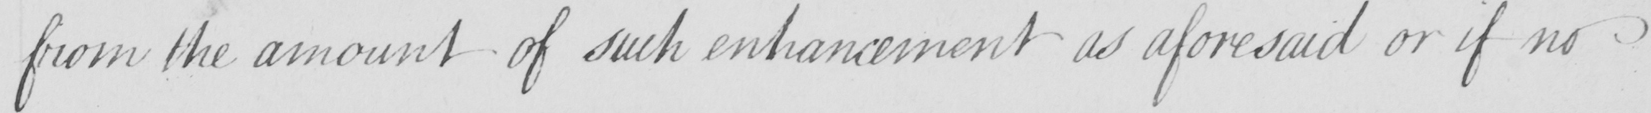What does this handwritten line say? from the amount of such enhancement as aforesaid or if no 